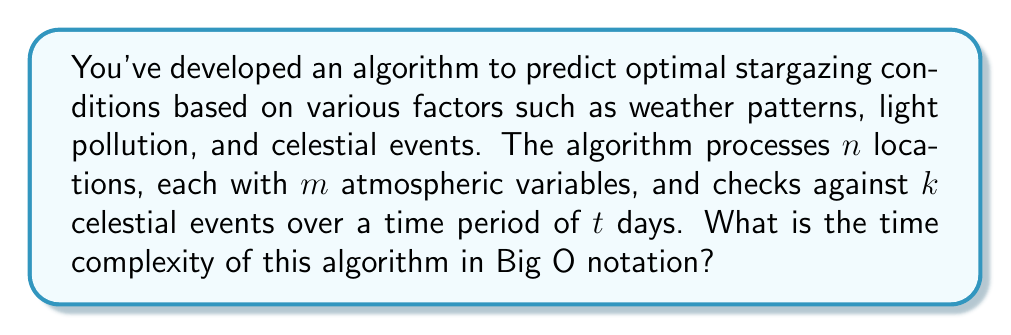Help me with this question. To analyze the time complexity of this algorithm, let's break it down step by step:

1. Processing locations: We have $n$ locations to process.

2. For each location, we need to consider $m$ atmospheric variables. This creates a nested loop:
   $$ O(n \cdot m) $$

3. For each combination of location and atmospheric variables, we need to check against $k$ celestial events. This adds another level of nesting:
   $$ O(n \cdot m \cdot k) $$

4. Finally, we're doing this for each day in the time period $t$. This gives us our final nested structure:
   $$ O(n \cdot m \cdot k \cdot t) $$

5. Assuming that the processing of each individual data point (the innermost operation) takes constant time, this nested structure represents our overall time complexity.

6. In Big O notation, we typically express this as a product of the variables:
   $$ O(nmkt) $$

It's worth noting that this analysis assumes that $n$, $m$, $k$, and $t$ are independent variables. In a real-world scenario, some of these might be related or constrained, which could affect the practical performance of the algorithm.
Answer: $O(nmkt)$ 